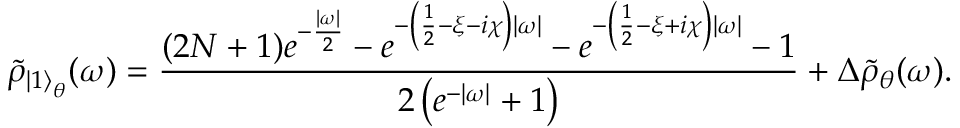Convert formula to latex. <formula><loc_0><loc_0><loc_500><loc_500>\tilde { \rho } _ { { \left | 1 \right \rangle } _ { \theta } } ( \omega ) = \frac { ( 2 N + 1 ) e ^ { - \frac { | \omega | } { 2 } } - e ^ { - \left ( \frac { 1 } { 2 } - \xi - i \chi \right ) | \omega | } - e ^ { - \left ( \frac { 1 } { 2 } - \xi + i \chi \right ) | \omega | } - 1 } { 2 \left ( e ^ { - | \omega | } + 1 \right ) } + \Delta \tilde { \rho } _ { \theta } ( \omega ) .</formula> 